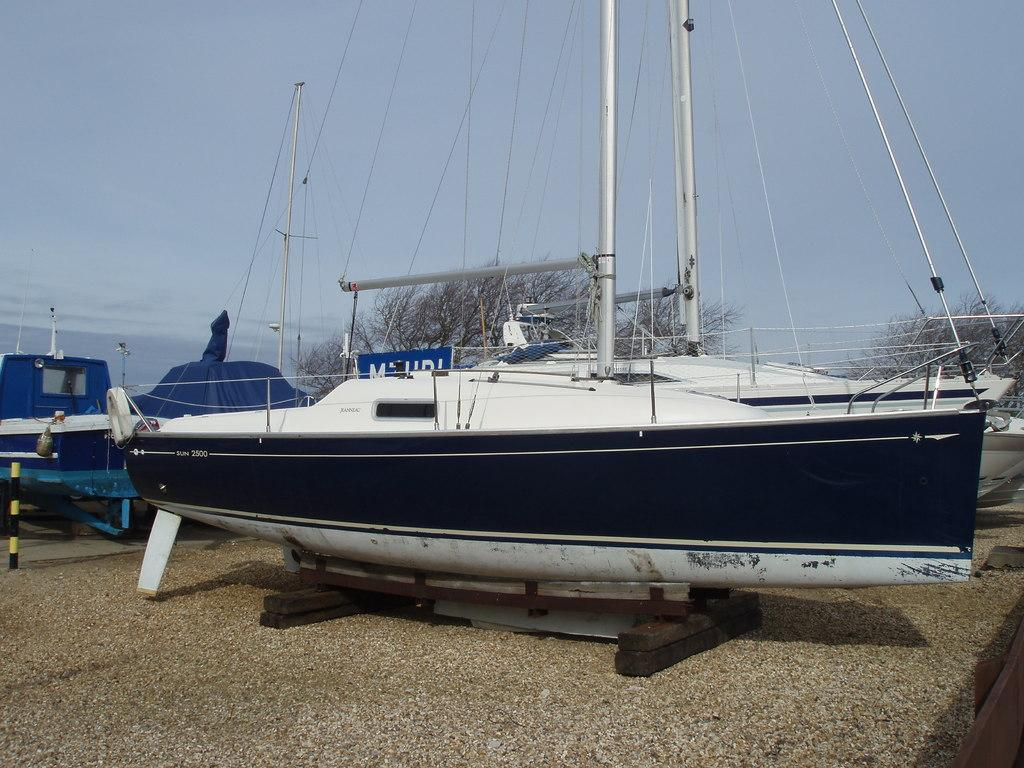What type of boat is in the center of the image? There is a sandbagger sloop in the center of the image. What type of pail is used to collect the substance in the image? There is no pail or substance present in the image; it features a sandbagger sloop. How many tickets are visible in the image? There are no tickets present in the image. 